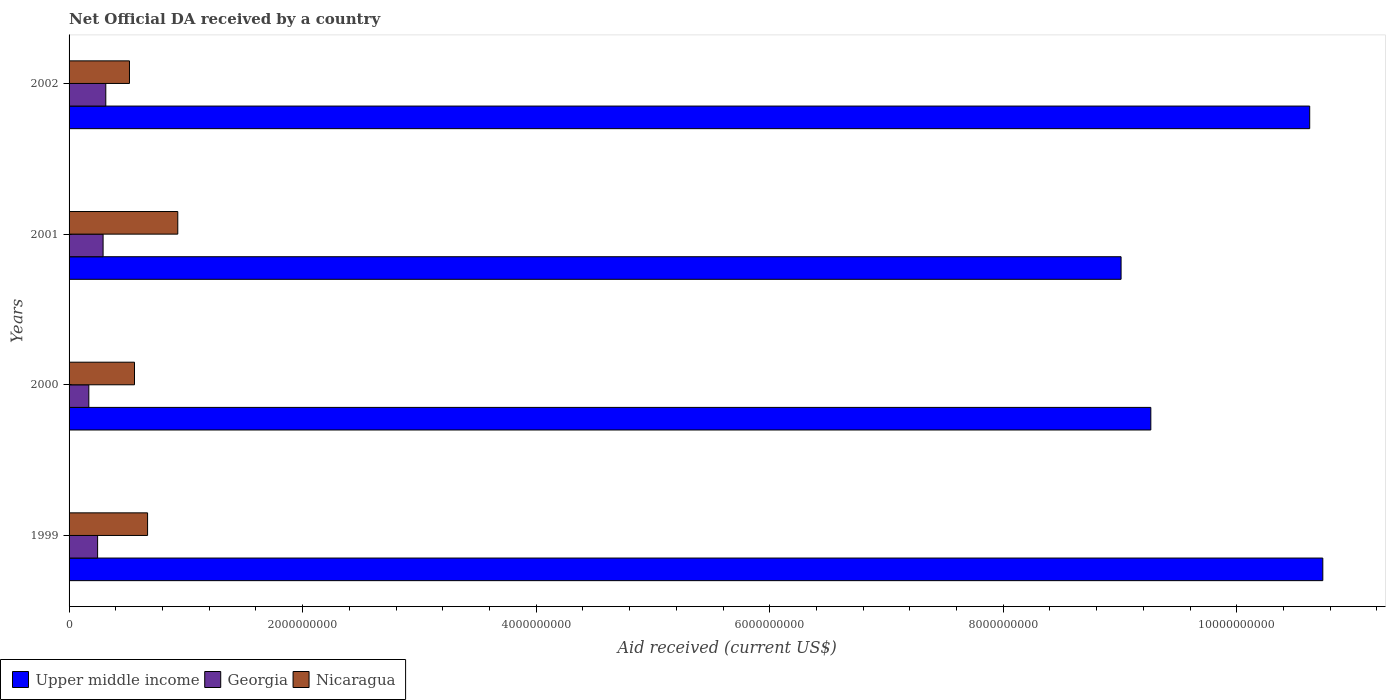How many different coloured bars are there?
Offer a very short reply. 3. How many groups of bars are there?
Give a very brief answer. 4. How many bars are there on the 2nd tick from the top?
Provide a succinct answer. 3. How many bars are there on the 1st tick from the bottom?
Keep it short and to the point. 3. In how many cases, is the number of bars for a given year not equal to the number of legend labels?
Offer a terse response. 0. What is the net official development assistance aid received in Georgia in 2002?
Your answer should be very brief. 3.14e+08. Across all years, what is the maximum net official development assistance aid received in Upper middle income?
Provide a succinct answer. 1.07e+1. Across all years, what is the minimum net official development assistance aid received in Georgia?
Provide a short and direct response. 1.69e+08. In which year was the net official development assistance aid received in Upper middle income maximum?
Ensure brevity in your answer.  1999. In which year was the net official development assistance aid received in Nicaragua minimum?
Your answer should be very brief. 2002. What is the total net official development assistance aid received in Nicaragua in the graph?
Your answer should be very brief. 2.68e+09. What is the difference between the net official development assistance aid received in Upper middle income in 2000 and that in 2002?
Offer a terse response. -1.36e+09. What is the difference between the net official development assistance aid received in Nicaragua in 2000 and the net official development assistance aid received in Upper middle income in 2002?
Provide a succinct answer. -1.01e+1. What is the average net official development assistance aid received in Georgia per year?
Provide a succinct answer. 2.55e+08. In the year 1999, what is the difference between the net official development assistance aid received in Nicaragua and net official development assistance aid received in Upper middle income?
Provide a short and direct response. -1.01e+1. In how many years, is the net official development assistance aid received in Upper middle income greater than 7200000000 US$?
Offer a very short reply. 4. What is the ratio of the net official development assistance aid received in Nicaragua in 1999 to that in 2002?
Ensure brevity in your answer.  1.3. Is the difference between the net official development assistance aid received in Nicaragua in 1999 and 2000 greater than the difference between the net official development assistance aid received in Upper middle income in 1999 and 2000?
Offer a very short reply. No. What is the difference between the highest and the second highest net official development assistance aid received in Upper middle income?
Your answer should be very brief. 1.12e+08. What is the difference between the highest and the lowest net official development assistance aid received in Georgia?
Your answer should be compact. 1.45e+08. What does the 2nd bar from the top in 2001 represents?
Your response must be concise. Georgia. What does the 3rd bar from the bottom in 1999 represents?
Provide a short and direct response. Nicaragua. How many bars are there?
Offer a terse response. 12. How many years are there in the graph?
Ensure brevity in your answer.  4. Does the graph contain grids?
Provide a short and direct response. No. Where does the legend appear in the graph?
Your response must be concise. Bottom left. How many legend labels are there?
Offer a terse response. 3. How are the legend labels stacked?
Your answer should be compact. Horizontal. What is the title of the graph?
Ensure brevity in your answer.  Net Official DA received by a country. What is the label or title of the X-axis?
Offer a terse response. Aid received (current US$). What is the label or title of the Y-axis?
Provide a succinct answer. Years. What is the Aid received (current US$) in Upper middle income in 1999?
Keep it short and to the point. 1.07e+1. What is the Aid received (current US$) of Georgia in 1999?
Your answer should be very brief. 2.44e+08. What is the Aid received (current US$) of Nicaragua in 1999?
Provide a short and direct response. 6.72e+08. What is the Aid received (current US$) of Upper middle income in 2000?
Give a very brief answer. 9.26e+09. What is the Aid received (current US$) in Georgia in 2000?
Your response must be concise. 1.69e+08. What is the Aid received (current US$) in Nicaragua in 2000?
Keep it short and to the point. 5.60e+08. What is the Aid received (current US$) of Upper middle income in 2001?
Give a very brief answer. 9.01e+09. What is the Aid received (current US$) of Georgia in 2001?
Offer a very short reply. 2.91e+08. What is the Aid received (current US$) in Nicaragua in 2001?
Provide a short and direct response. 9.31e+08. What is the Aid received (current US$) of Upper middle income in 2002?
Offer a very short reply. 1.06e+1. What is the Aid received (current US$) of Georgia in 2002?
Keep it short and to the point. 3.14e+08. What is the Aid received (current US$) in Nicaragua in 2002?
Your answer should be very brief. 5.17e+08. Across all years, what is the maximum Aid received (current US$) in Upper middle income?
Keep it short and to the point. 1.07e+1. Across all years, what is the maximum Aid received (current US$) of Georgia?
Your answer should be compact. 3.14e+08. Across all years, what is the maximum Aid received (current US$) of Nicaragua?
Provide a succinct answer. 9.31e+08. Across all years, what is the minimum Aid received (current US$) of Upper middle income?
Provide a short and direct response. 9.01e+09. Across all years, what is the minimum Aid received (current US$) in Georgia?
Provide a succinct answer. 1.69e+08. Across all years, what is the minimum Aid received (current US$) of Nicaragua?
Provide a short and direct response. 5.17e+08. What is the total Aid received (current US$) of Upper middle income in the graph?
Offer a terse response. 3.96e+1. What is the total Aid received (current US$) of Georgia in the graph?
Make the answer very short. 1.02e+09. What is the total Aid received (current US$) in Nicaragua in the graph?
Keep it short and to the point. 2.68e+09. What is the difference between the Aid received (current US$) in Upper middle income in 1999 and that in 2000?
Your answer should be compact. 1.47e+09. What is the difference between the Aid received (current US$) in Georgia in 1999 and that in 2000?
Provide a succinct answer. 7.52e+07. What is the difference between the Aid received (current US$) of Nicaragua in 1999 and that in 2000?
Your response must be concise. 1.12e+08. What is the difference between the Aid received (current US$) in Upper middle income in 1999 and that in 2001?
Make the answer very short. 1.73e+09. What is the difference between the Aid received (current US$) of Georgia in 1999 and that in 2001?
Your answer should be compact. -4.70e+07. What is the difference between the Aid received (current US$) in Nicaragua in 1999 and that in 2001?
Offer a very short reply. -2.59e+08. What is the difference between the Aid received (current US$) in Upper middle income in 1999 and that in 2002?
Give a very brief answer. 1.12e+08. What is the difference between the Aid received (current US$) in Georgia in 1999 and that in 2002?
Your answer should be very brief. -7.01e+07. What is the difference between the Aid received (current US$) of Nicaragua in 1999 and that in 2002?
Your answer should be very brief. 1.55e+08. What is the difference between the Aid received (current US$) of Upper middle income in 2000 and that in 2001?
Your response must be concise. 2.55e+08. What is the difference between the Aid received (current US$) of Georgia in 2000 and that in 2001?
Provide a succinct answer. -1.22e+08. What is the difference between the Aid received (current US$) in Nicaragua in 2000 and that in 2001?
Offer a terse response. -3.71e+08. What is the difference between the Aid received (current US$) of Upper middle income in 2000 and that in 2002?
Provide a succinct answer. -1.36e+09. What is the difference between the Aid received (current US$) in Georgia in 2000 and that in 2002?
Your answer should be very brief. -1.45e+08. What is the difference between the Aid received (current US$) in Nicaragua in 2000 and that in 2002?
Keep it short and to the point. 4.32e+07. What is the difference between the Aid received (current US$) of Upper middle income in 2001 and that in 2002?
Offer a terse response. -1.62e+09. What is the difference between the Aid received (current US$) in Georgia in 2001 and that in 2002?
Provide a succinct answer. -2.31e+07. What is the difference between the Aid received (current US$) in Nicaragua in 2001 and that in 2002?
Keep it short and to the point. 4.14e+08. What is the difference between the Aid received (current US$) of Upper middle income in 1999 and the Aid received (current US$) of Georgia in 2000?
Make the answer very short. 1.06e+1. What is the difference between the Aid received (current US$) of Upper middle income in 1999 and the Aid received (current US$) of Nicaragua in 2000?
Offer a terse response. 1.02e+1. What is the difference between the Aid received (current US$) of Georgia in 1999 and the Aid received (current US$) of Nicaragua in 2000?
Offer a terse response. -3.16e+08. What is the difference between the Aid received (current US$) of Upper middle income in 1999 and the Aid received (current US$) of Georgia in 2001?
Keep it short and to the point. 1.04e+1. What is the difference between the Aid received (current US$) of Upper middle income in 1999 and the Aid received (current US$) of Nicaragua in 2001?
Offer a very short reply. 9.81e+09. What is the difference between the Aid received (current US$) in Georgia in 1999 and the Aid received (current US$) in Nicaragua in 2001?
Give a very brief answer. -6.87e+08. What is the difference between the Aid received (current US$) of Upper middle income in 1999 and the Aid received (current US$) of Georgia in 2002?
Make the answer very short. 1.04e+1. What is the difference between the Aid received (current US$) in Upper middle income in 1999 and the Aid received (current US$) in Nicaragua in 2002?
Your answer should be very brief. 1.02e+1. What is the difference between the Aid received (current US$) in Georgia in 1999 and the Aid received (current US$) in Nicaragua in 2002?
Provide a succinct answer. -2.73e+08. What is the difference between the Aid received (current US$) of Upper middle income in 2000 and the Aid received (current US$) of Georgia in 2001?
Ensure brevity in your answer.  8.97e+09. What is the difference between the Aid received (current US$) of Upper middle income in 2000 and the Aid received (current US$) of Nicaragua in 2001?
Offer a terse response. 8.33e+09. What is the difference between the Aid received (current US$) of Georgia in 2000 and the Aid received (current US$) of Nicaragua in 2001?
Make the answer very short. -7.62e+08. What is the difference between the Aid received (current US$) in Upper middle income in 2000 and the Aid received (current US$) in Georgia in 2002?
Your answer should be compact. 8.95e+09. What is the difference between the Aid received (current US$) in Upper middle income in 2000 and the Aid received (current US$) in Nicaragua in 2002?
Offer a very short reply. 8.75e+09. What is the difference between the Aid received (current US$) of Georgia in 2000 and the Aid received (current US$) of Nicaragua in 2002?
Offer a very short reply. -3.48e+08. What is the difference between the Aid received (current US$) of Upper middle income in 2001 and the Aid received (current US$) of Georgia in 2002?
Your answer should be very brief. 8.69e+09. What is the difference between the Aid received (current US$) of Upper middle income in 2001 and the Aid received (current US$) of Nicaragua in 2002?
Provide a short and direct response. 8.49e+09. What is the difference between the Aid received (current US$) of Georgia in 2001 and the Aid received (current US$) of Nicaragua in 2002?
Your response must be concise. -2.26e+08. What is the average Aid received (current US$) in Upper middle income per year?
Make the answer very short. 9.91e+09. What is the average Aid received (current US$) of Georgia per year?
Your answer should be very brief. 2.55e+08. What is the average Aid received (current US$) of Nicaragua per year?
Offer a very short reply. 6.70e+08. In the year 1999, what is the difference between the Aid received (current US$) of Upper middle income and Aid received (current US$) of Georgia?
Keep it short and to the point. 1.05e+1. In the year 1999, what is the difference between the Aid received (current US$) in Upper middle income and Aid received (current US$) in Nicaragua?
Offer a very short reply. 1.01e+1. In the year 1999, what is the difference between the Aid received (current US$) in Georgia and Aid received (current US$) in Nicaragua?
Offer a very short reply. -4.28e+08. In the year 2000, what is the difference between the Aid received (current US$) in Upper middle income and Aid received (current US$) in Georgia?
Provide a short and direct response. 9.09e+09. In the year 2000, what is the difference between the Aid received (current US$) in Upper middle income and Aid received (current US$) in Nicaragua?
Give a very brief answer. 8.70e+09. In the year 2000, what is the difference between the Aid received (current US$) of Georgia and Aid received (current US$) of Nicaragua?
Your response must be concise. -3.91e+08. In the year 2001, what is the difference between the Aid received (current US$) of Upper middle income and Aid received (current US$) of Georgia?
Your response must be concise. 8.72e+09. In the year 2001, what is the difference between the Aid received (current US$) in Upper middle income and Aid received (current US$) in Nicaragua?
Offer a terse response. 8.08e+09. In the year 2001, what is the difference between the Aid received (current US$) in Georgia and Aid received (current US$) in Nicaragua?
Offer a very short reply. -6.40e+08. In the year 2002, what is the difference between the Aid received (current US$) of Upper middle income and Aid received (current US$) of Georgia?
Offer a terse response. 1.03e+1. In the year 2002, what is the difference between the Aid received (current US$) of Upper middle income and Aid received (current US$) of Nicaragua?
Keep it short and to the point. 1.01e+1. In the year 2002, what is the difference between the Aid received (current US$) of Georgia and Aid received (current US$) of Nicaragua?
Give a very brief answer. -2.03e+08. What is the ratio of the Aid received (current US$) of Upper middle income in 1999 to that in 2000?
Your response must be concise. 1.16. What is the ratio of the Aid received (current US$) in Georgia in 1999 to that in 2000?
Provide a short and direct response. 1.44. What is the ratio of the Aid received (current US$) in Nicaragua in 1999 to that in 2000?
Your response must be concise. 1.2. What is the ratio of the Aid received (current US$) in Upper middle income in 1999 to that in 2001?
Make the answer very short. 1.19. What is the ratio of the Aid received (current US$) of Georgia in 1999 to that in 2001?
Provide a succinct answer. 0.84. What is the ratio of the Aid received (current US$) in Nicaragua in 1999 to that in 2001?
Your answer should be compact. 0.72. What is the ratio of the Aid received (current US$) in Upper middle income in 1999 to that in 2002?
Keep it short and to the point. 1.01. What is the ratio of the Aid received (current US$) in Georgia in 1999 to that in 2002?
Ensure brevity in your answer.  0.78. What is the ratio of the Aid received (current US$) in Nicaragua in 1999 to that in 2002?
Provide a short and direct response. 1.3. What is the ratio of the Aid received (current US$) of Upper middle income in 2000 to that in 2001?
Offer a very short reply. 1.03. What is the ratio of the Aid received (current US$) of Georgia in 2000 to that in 2001?
Offer a very short reply. 0.58. What is the ratio of the Aid received (current US$) of Nicaragua in 2000 to that in 2001?
Your answer should be compact. 0.6. What is the ratio of the Aid received (current US$) in Upper middle income in 2000 to that in 2002?
Offer a very short reply. 0.87. What is the ratio of the Aid received (current US$) in Georgia in 2000 to that in 2002?
Your answer should be compact. 0.54. What is the ratio of the Aid received (current US$) of Nicaragua in 2000 to that in 2002?
Make the answer very short. 1.08. What is the ratio of the Aid received (current US$) of Upper middle income in 2001 to that in 2002?
Provide a short and direct response. 0.85. What is the ratio of the Aid received (current US$) of Georgia in 2001 to that in 2002?
Your answer should be very brief. 0.93. What is the ratio of the Aid received (current US$) in Nicaragua in 2001 to that in 2002?
Make the answer very short. 1.8. What is the difference between the highest and the second highest Aid received (current US$) in Upper middle income?
Keep it short and to the point. 1.12e+08. What is the difference between the highest and the second highest Aid received (current US$) of Georgia?
Give a very brief answer. 2.31e+07. What is the difference between the highest and the second highest Aid received (current US$) in Nicaragua?
Offer a terse response. 2.59e+08. What is the difference between the highest and the lowest Aid received (current US$) of Upper middle income?
Keep it short and to the point. 1.73e+09. What is the difference between the highest and the lowest Aid received (current US$) in Georgia?
Your answer should be very brief. 1.45e+08. What is the difference between the highest and the lowest Aid received (current US$) in Nicaragua?
Provide a short and direct response. 4.14e+08. 